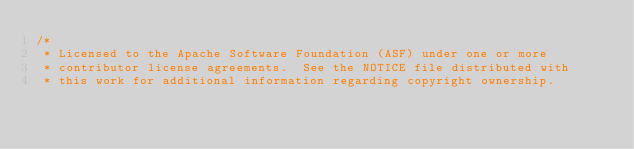<code> <loc_0><loc_0><loc_500><loc_500><_Java_>/*
 * Licensed to the Apache Software Foundation (ASF) under one or more
 * contributor license agreements.  See the NOTICE file distributed with
 * this work for additional information regarding copyright ownership.</code> 